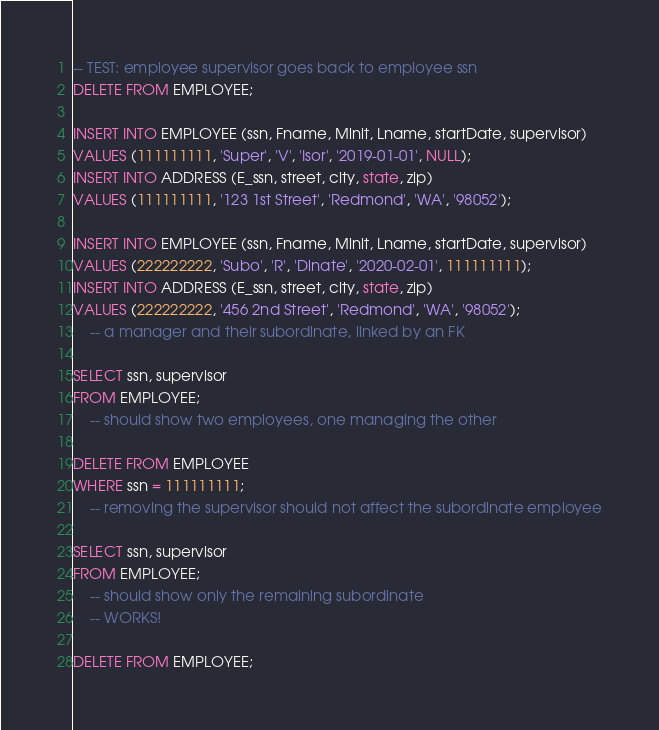Convert code to text. <code><loc_0><loc_0><loc_500><loc_500><_SQL_>-- TEST: employee supervisor goes back to employee ssn
DELETE FROM EMPLOYEE;

INSERT INTO EMPLOYEE (ssn, Fname, Minit, Lname, startDate, supervisor)
VALUES (111111111, 'Super', 'V', 'Isor', '2019-01-01', NULL);
INSERT INTO ADDRESS (E_ssn, street, city, state, zip) 
VALUES (111111111, '123 1st Street', 'Redmond', 'WA', '98052');

INSERT INTO EMPLOYEE (ssn, Fname, Minit, Lname, startDate, supervisor)
VALUES (222222222, 'Subo', 'R', 'Dinate', '2020-02-01', 111111111);
INSERT INTO ADDRESS (E_ssn, street, city, state, zip) 
VALUES (222222222, '456 2nd Street', 'Redmond', 'WA', '98052');
	-- a manager and their subordinate, linked by an FK

SELECT ssn, supervisor
FROM EMPLOYEE;
	-- should show two employees, one managing the other

DELETE FROM EMPLOYEE
WHERE ssn = 111111111;
	-- removing the supervisor should not affect the subordinate employee
	
SELECT ssn, supervisor
FROM EMPLOYEE;
	-- should show only the remaining subordinate
	-- WORKS!
	
DELETE FROM EMPLOYEE;</code> 